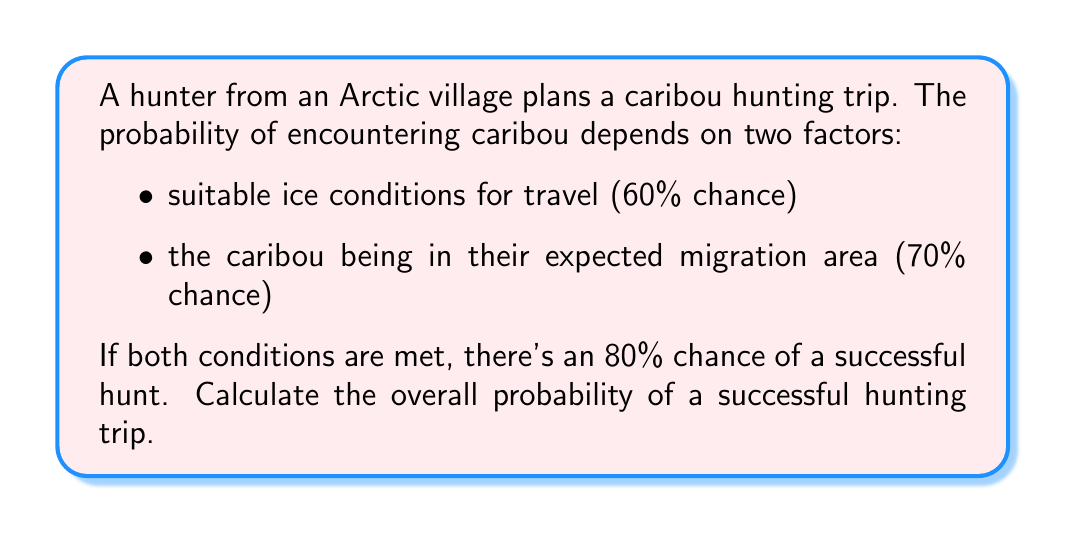Could you help me with this problem? Let's approach this step-by-step using probability theory:

1) Define events:
   A: Suitable ice conditions (P(A) = 0.60)
   B: Caribou in expected area (P(B) = 0.70)
   C: Successful hunt given both conditions are met (P(C|A∩B) = 0.80)

2) We need to find P(C), the probability of a successful hunt.

3) Using the law of total probability:
   $$P(C) = P(C|A∩B) \cdot P(A∩B)$$

4) Assuming A and B are independent events:
   $$P(A∩B) = P(A) \cdot P(B) = 0.60 \cdot 0.70 = 0.42$$

5) Now we can calculate P(C):
   $$P(C) = 0.80 \cdot 0.42 = 0.336$$

6) Convert to percentage:
   $$0.336 \cdot 100\% = 33.6\%$$
Answer: The overall probability of a successful hunting trip is 33.6%. 